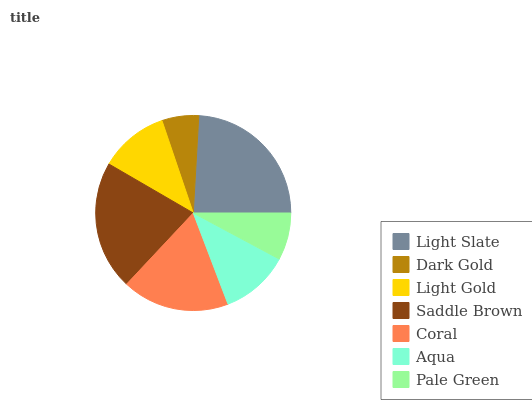Is Dark Gold the minimum?
Answer yes or no. Yes. Is Light Slate the maximum?
Answer yes or no. Yes. Is Light Gold the minimum?
Answer yes or no. No. Is Light Gold the maximum?
Answer yes or no. No. Is Light Gold greater than Dark Gold?
Answer yes or no. Yes. Is Dark Gold less than Light Gold?
Answer yes or no. Yes. Is Dark Gold greater than Light Gold?
Answer yes or no. No. Is Light Gold less than Dark Gold?
Answer yes or no. No. Is Light Gold the high median?
Answer yes or no. Yes. Is Light Gold the low median?
Answer yes or no. Yes. Is Pale Green the high median?
Answer yes or no. No. Is Aqua the low median?
Answer yes or no. No. 